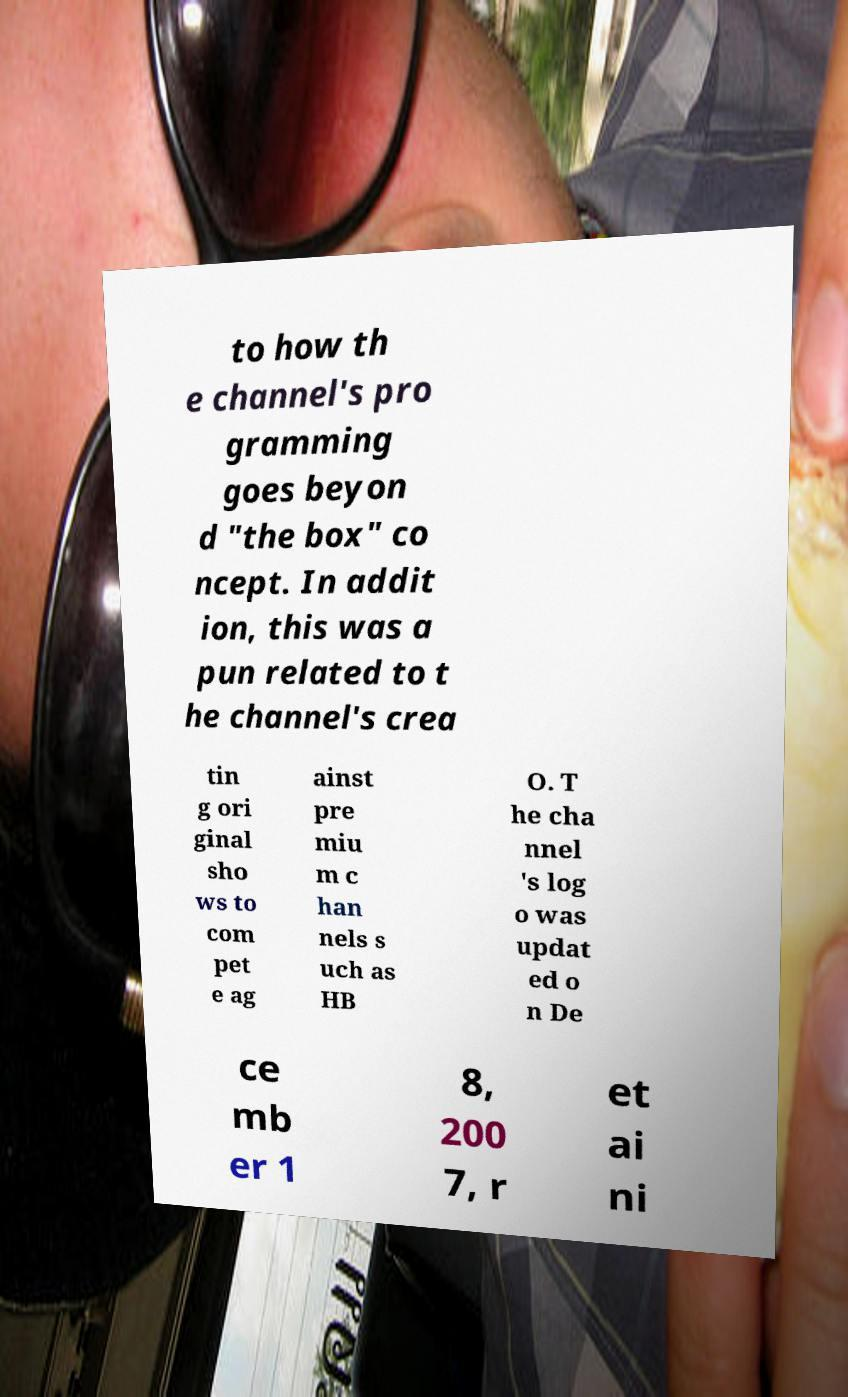Please read and relay the text visible in this image. What does it say? to how th e channel's pro gramming goes beyon d "the box" co ncept. In addit ion, this was a pun related to t he channel's crea tin g ori ginal sho ws to com pet e ag ainst pre miu m c han nels s uch as HB O. T he cha nnel 's log o was updat ed o n De ce mb er 1 8, 200 7, r et ai ni 